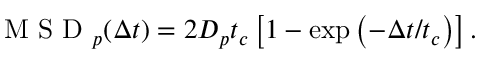<formula> <loc_0><loc_0><loc_500><loc_500>\begin{array} { r } { M S D _ { p } ( \Delta t ) = 2 D _ { p } t _ { c } \left [ 1 - \exp \left ( - \Delta t / t _ { c } \right ) \right ] . } \end{array}</formula> 